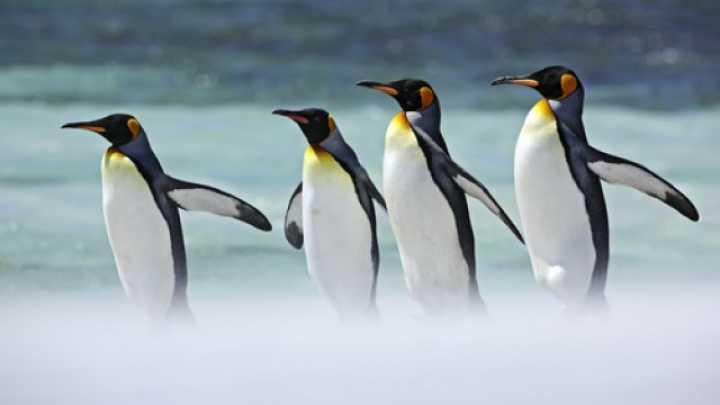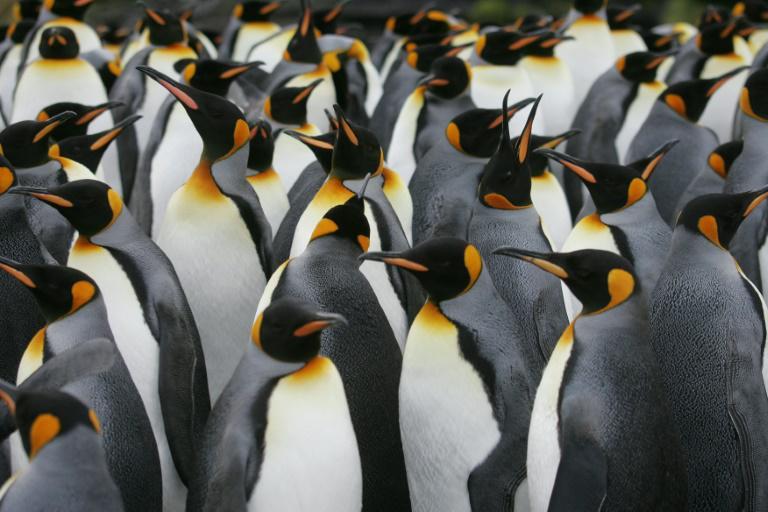The first image is the image on the left, the second image is the image on the right. Evaluate the accuracy of this statement regarding the images: "The left image has no more than 4 penguins". Is it true? Answer yes or no. Yes. 